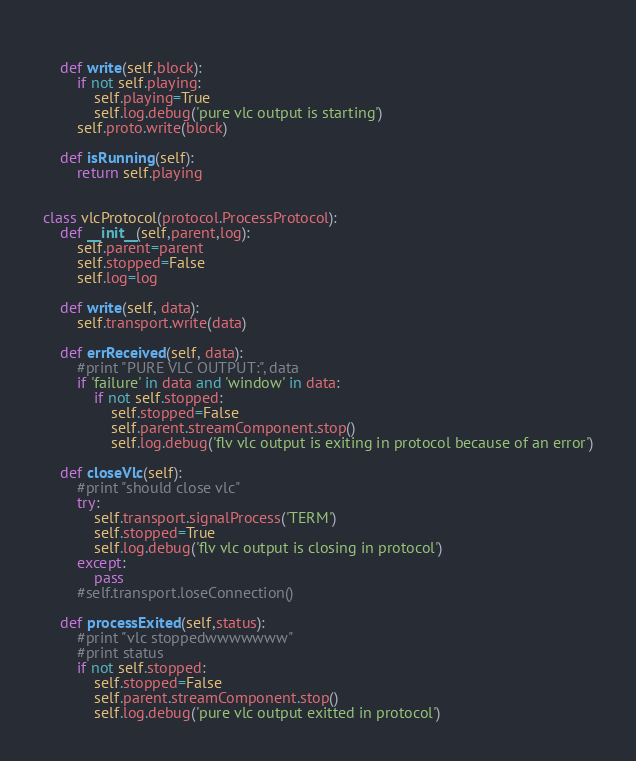<code> <loc_0><loc_0><loc_500><loc_500><_Python_>        
    def write(self,block):
        if not self.playing:
            self.playing=True
            self.log.debug('pure vlc output is starting')
        self.proto.write(block)

    def isRunning(self):
        return self.playing

        
class vlcProtocol(protocol.ProcessProtocol):
    def __init__(self,parent,log):
        self.parent=parent
        self.stopped=False
        self.log=log
    
    def write(self, data):
        self.transport.write(data)
    
    def errReceived(self, data):
        #print "PURE VLC OUTPUT:", data
        if 'failure' in data and 'window' in data:
            if not self.stopped:
                self.stopped=False
                self.parent.streamComponent.stop()
                self.log.debug('flv vlc output is exiting in protocol because of an error')
                
    def closeVlc(self):
        #print "should close vlc"
        try:
            self.transport.signalProcess('TERM')
            self.stopped=True
            self.log.debug('flv vlc output is closing in protocol')
        except:
            pass
        #self.transport.loseConnection()

    def processExited(self,status):
        #print "vlc stoppedwwwwwww"
        #print status
        if not self.stopped:
            self.stopped=False
            self.parent.streamComponent.stop()
            self.log.debug('pure vlc output exitted in protocol')
</code> 